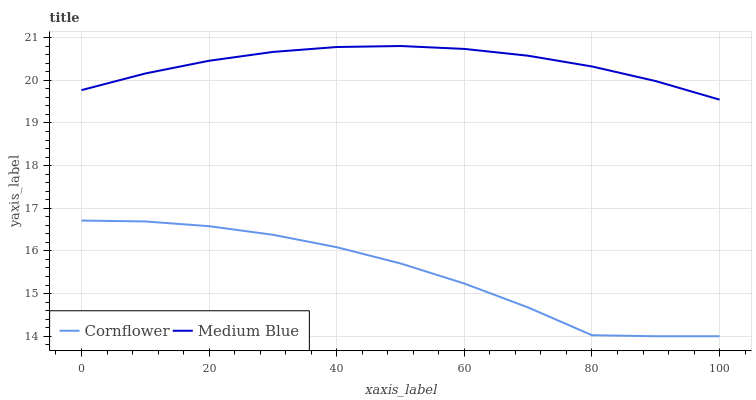Does Cornflower have the minimum area under the curve?
Answer yes or no. Yes. Does Medium Blue have the maximum area under the curve?
Answer yes or no. Yes. Does Medium Blue have the minimum area under the curve?
Answer yes or no. No. Is Medium Blue the smoothest?
Answer yes or no. Yes. Is Cornflower the roughest?
Answer yes or no. Yes. Is Medium Blue the roughest?
Answer yes or no. No. Does Cornflower have the lowest value?
Answer yes or no. Yes. Does Medium Blue have the lowest value?
Answer yes or no. No. Does Medium Blue have the highest value?
Answer yes or no. Yes. Is Cornflower less than Medium Blue?
Answer yes or no. Yes. Is Medium Blue greater than Cornflower?
Answer yes or no. Yes. Does Cornflower intersect Medium Blue?
Answer yes or no. No. 